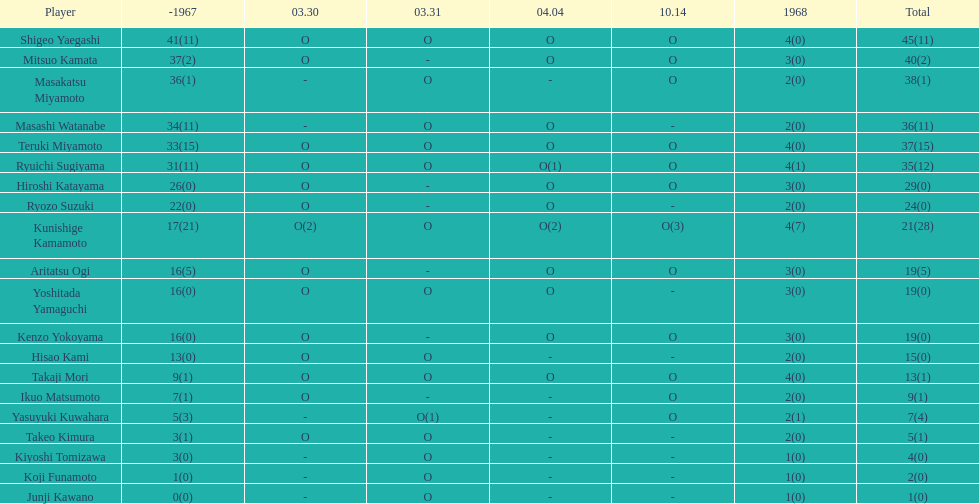In that particular year, how many players appeared on the field? 20. Can you give me this table as a dict? {'header': ['Player', '-1967', '03.30', '03.31', '04.04', '10.14', '1968', 'Total'], 'rows': [['Shigeo Yaegashi', '41(11)', 'O', 'O', 'O', 'O', '4(0)', '45(11)'], ['Mitsuo Kamata', '37(2)', 'O', '-', 'O', 'O', '3(0)', '40(2)'], ['Masakatsu Miyamoto', '36(1)', '-', 'O', '-', 'O', '2(0)', '38(1)'], ['Masashi Watanabe', '34(11)', '-', 'O', 'O', '-', '2(0)', '36(11)'], ['Teruki Miyamoto', '33(15)', 'O', 'O', 'O', 'O', '4(0)', '37(15)'], ['Ryuichi Sugiyama', '31(11)', 'O', 'O', 'O(1)', 'O', '4(1)', '35(12)'], ['Hiroshi Katayama', '26(0)', 'O', '-', 'O', 'O', '3(0)', '29(0)'], ['Ryozo Suzuki', '22(0)', 'O', '-', 'O', '-', '2(0)', '24(0)'], ['Kunishige Kamamoto', '17(21)', 'O(2)', 'O', 'O(2)', 'O(3)', '4(7)', '21(28)'], ['Aritatsu Ogi', '16(5)', 'O', '-', 'O', 'O', '3(0)', '19(5)'], ['Yoshitada Yamaguchi', '16(0)', 'O', 'O', 'O', '-', '3(0)', '19(0)'], ['Kenzo Yokoyama', '16(0)', 'O', '-', 'O', 'O', '3(0)', '19(0)'], ['Hisao Kami', '13(0)', 'O', 'O', '-', '-', '2(0)', '15(0)'], ['Takaji Mori', '9(1)', 'O', 'O', 'O', 'O', '4(0)', '13(1)'], ['Ikuo Matsumoto', '7(1)', 'O', '-', '-', 'O', '2(0)', '9(1)'], ['Yasuyuki Kuwahara', '5(3)', '-', 'O(1)', '-', 'O', '2(1)', '7(4)'], ['Takeo Kimura', '3(1)', 'O', 'O', '-', '-', '2(0)', '5(1)'], ['Kiyoshi Tomizawa', '3(0)', '-', 'O', '-', '-', '1(0)', '4(0)'], ['Koji Funamoto', '1(0)', '-', 'O', '-', '-', '1(0)', '2(0)'], ['Junji Kawano', '0(0)', '-', 'O', '-', '-', '1(0)', '1(0)']]} 